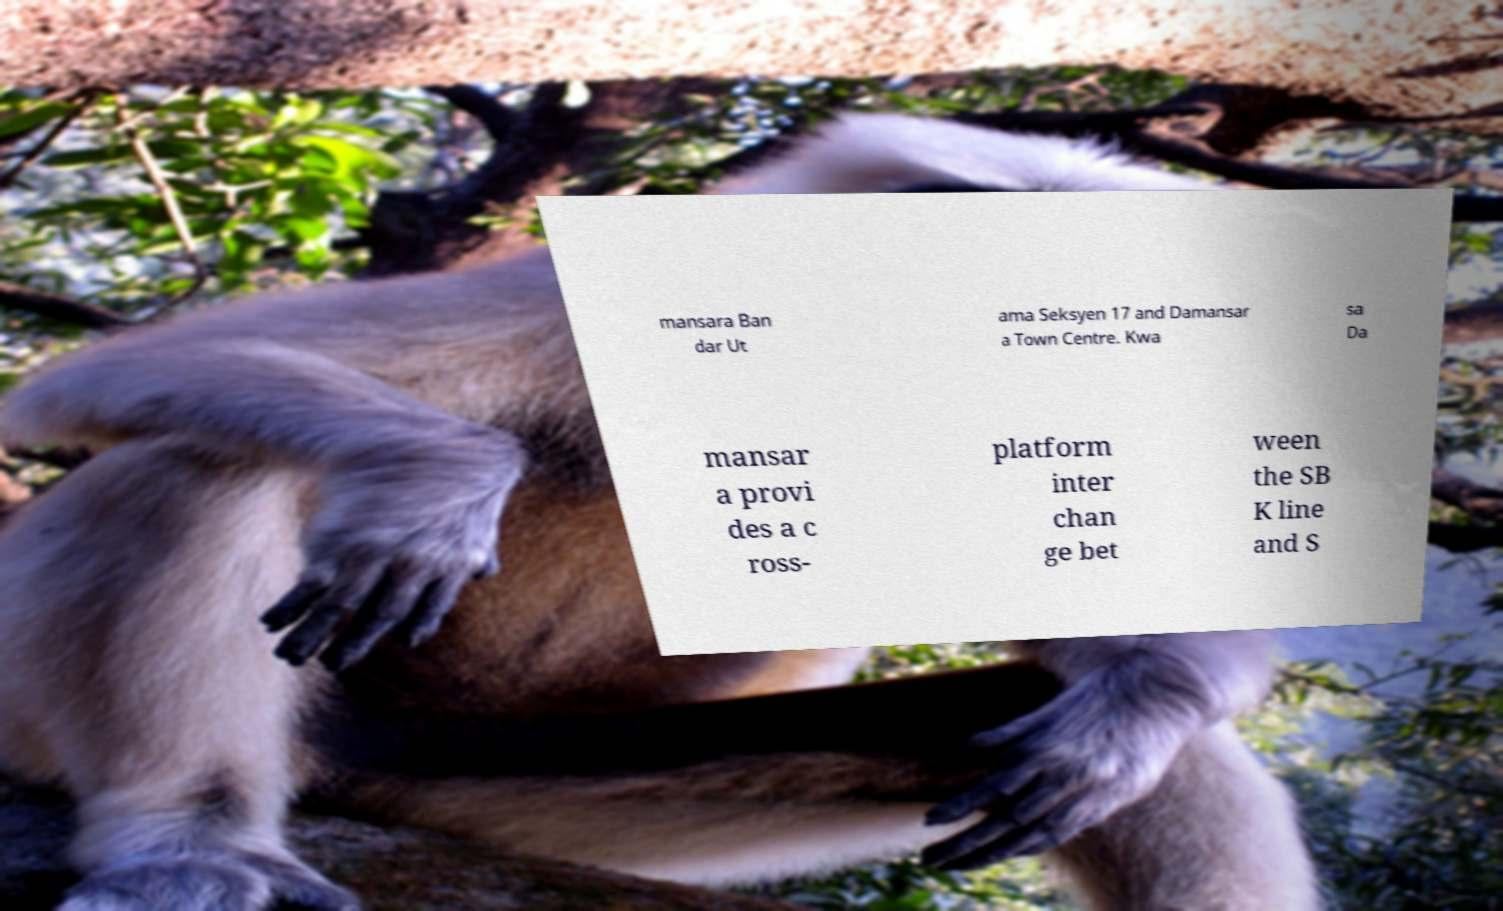Please read and relay the text visible in this image. What does it say? mansara Ban dar Ut ama Seksyen 17 and Damansar a Town Centre. Kwa sa Da mansar a provi des a c ross- platform inter chan ge bet ween the SB K line and S 